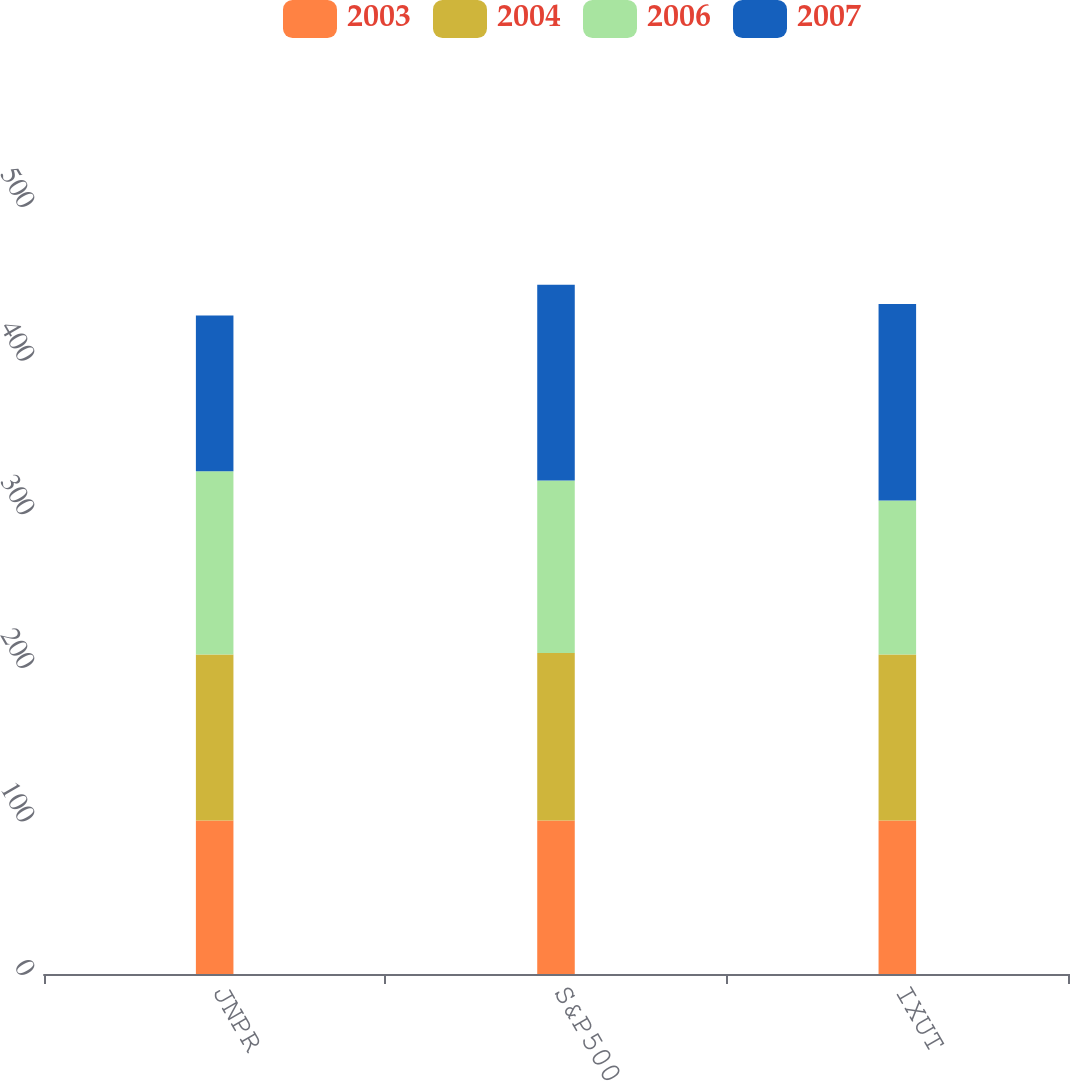Convert chart to OTSL. <chart><loc_0><loc_0><loc_500><loc_500><stacked_bar_chart><ecel><fcel>JNPR<fcel>S&P500<fcel>IXUT<nl><fcel>2003<fcel>100<fcel>100<fcel>100<nl><fcel>2004<fcel>108<fcel>108.99<fcel>108<nl><fcel>2006<fcel>119.38<fcel>112.26<fcel>100.21<nl><fcel>2007<fcel>101.39<fcel>127.55<fcel>128.03<nl></chart> 